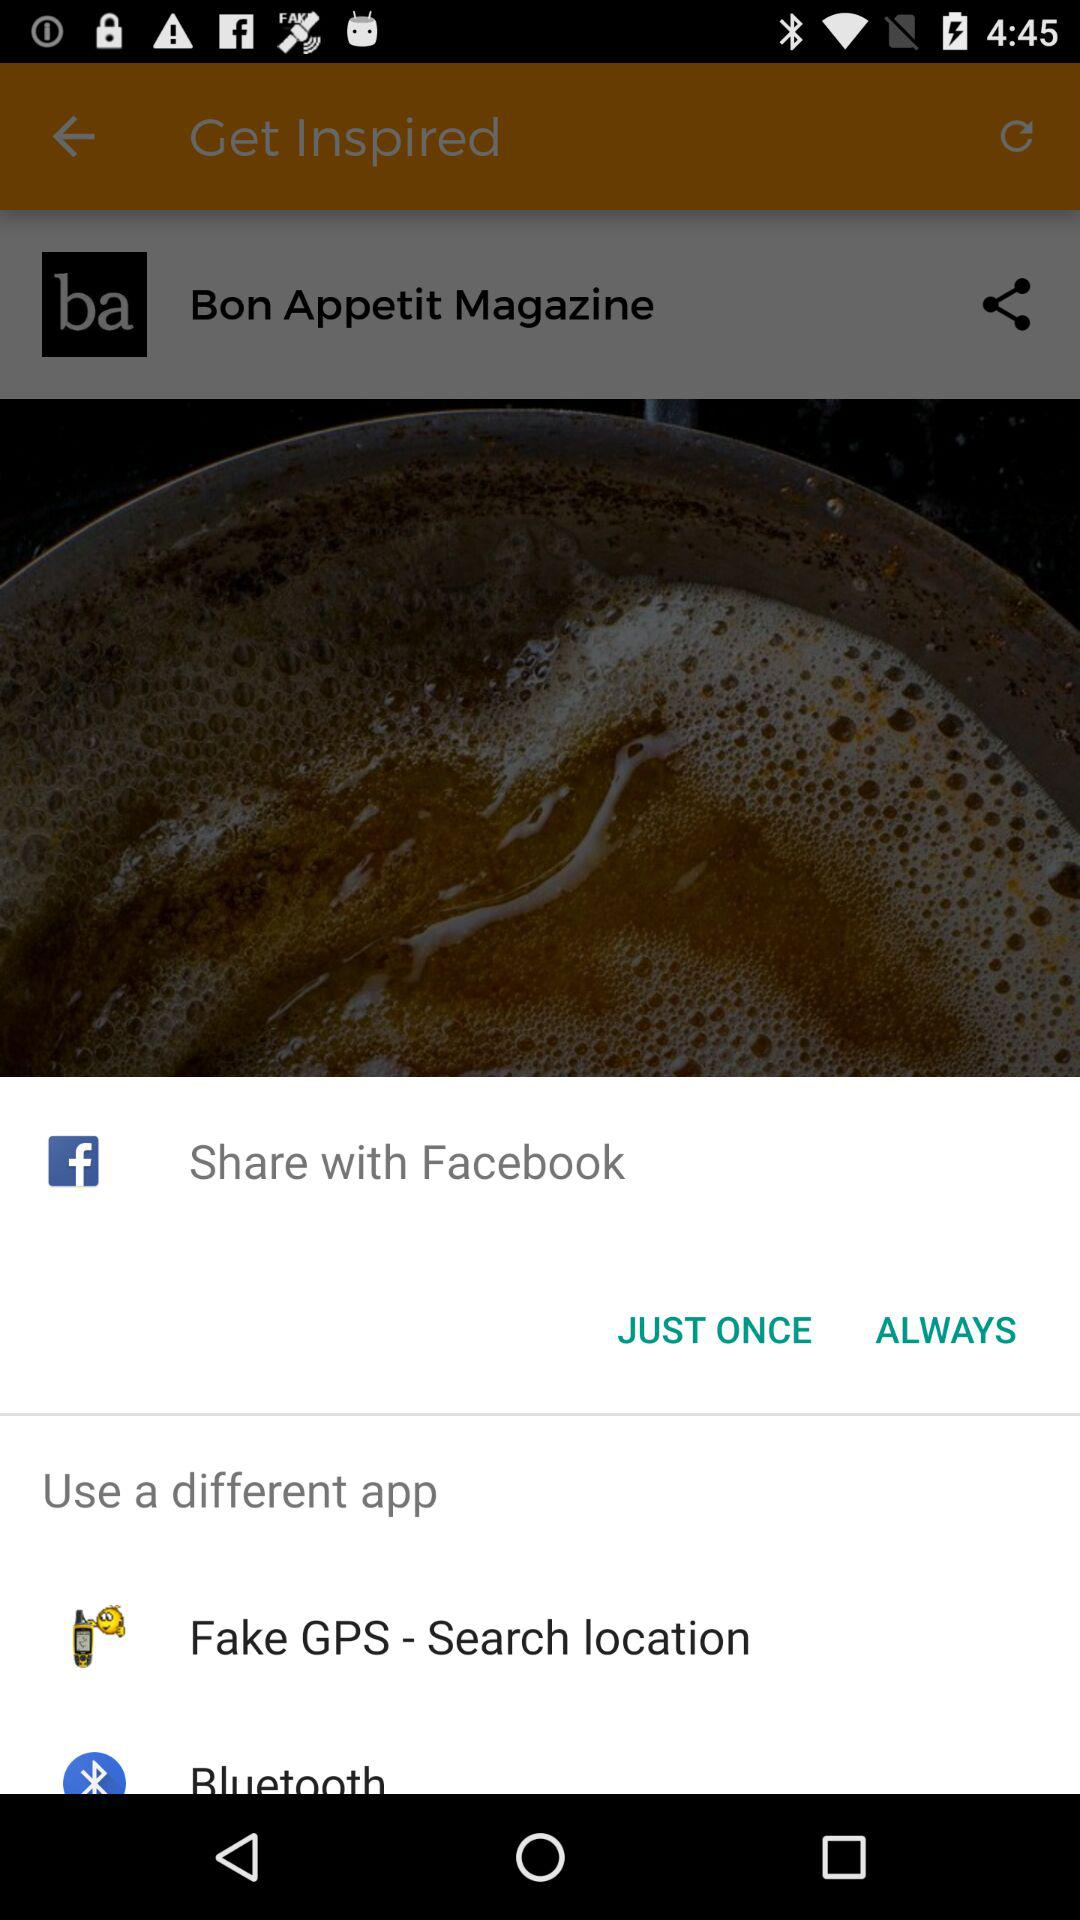What applications can be utilised to share the information? The applications that can be utilised to share the information are "Facebook", "Fake GPS - Search location" and "Bluetooth". 